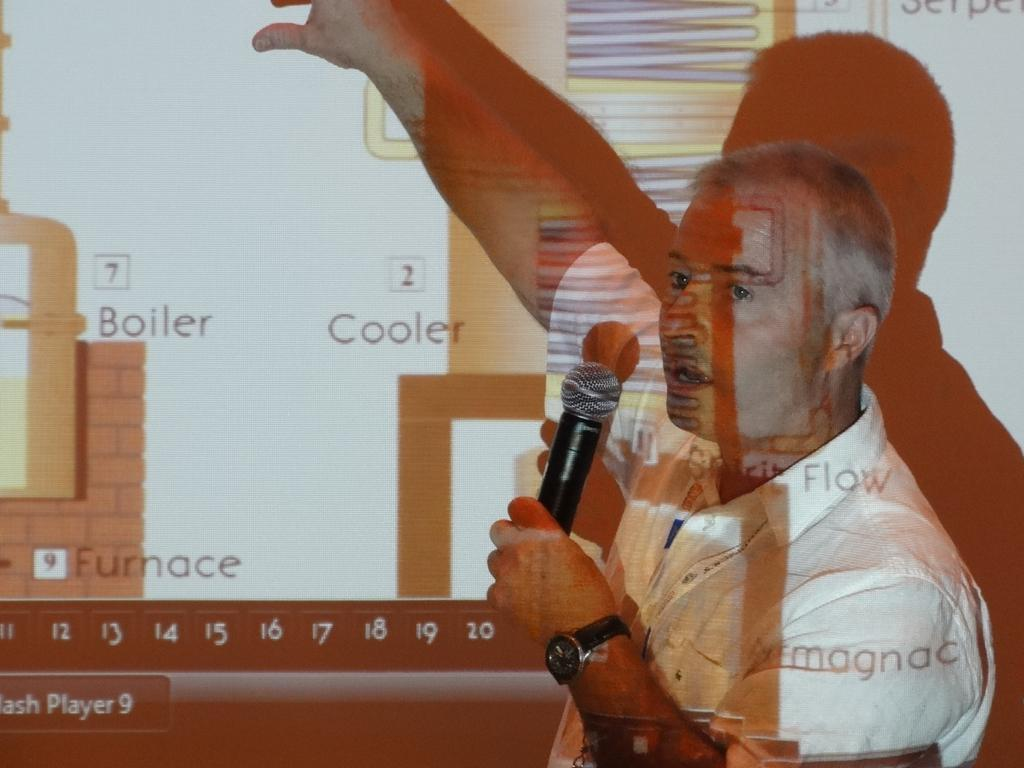What is the person in the image doing? The person in the image is talking on a mic and explaining something on a screen. What might the person be presenting or discussing? It is not clear from the image what the person is presenting or discussing, but they are using a mic and a screen to communicate their message. What type of flower is being lifted by the person in the image? There is no flower present in the image, and the person is not lifting anything. 